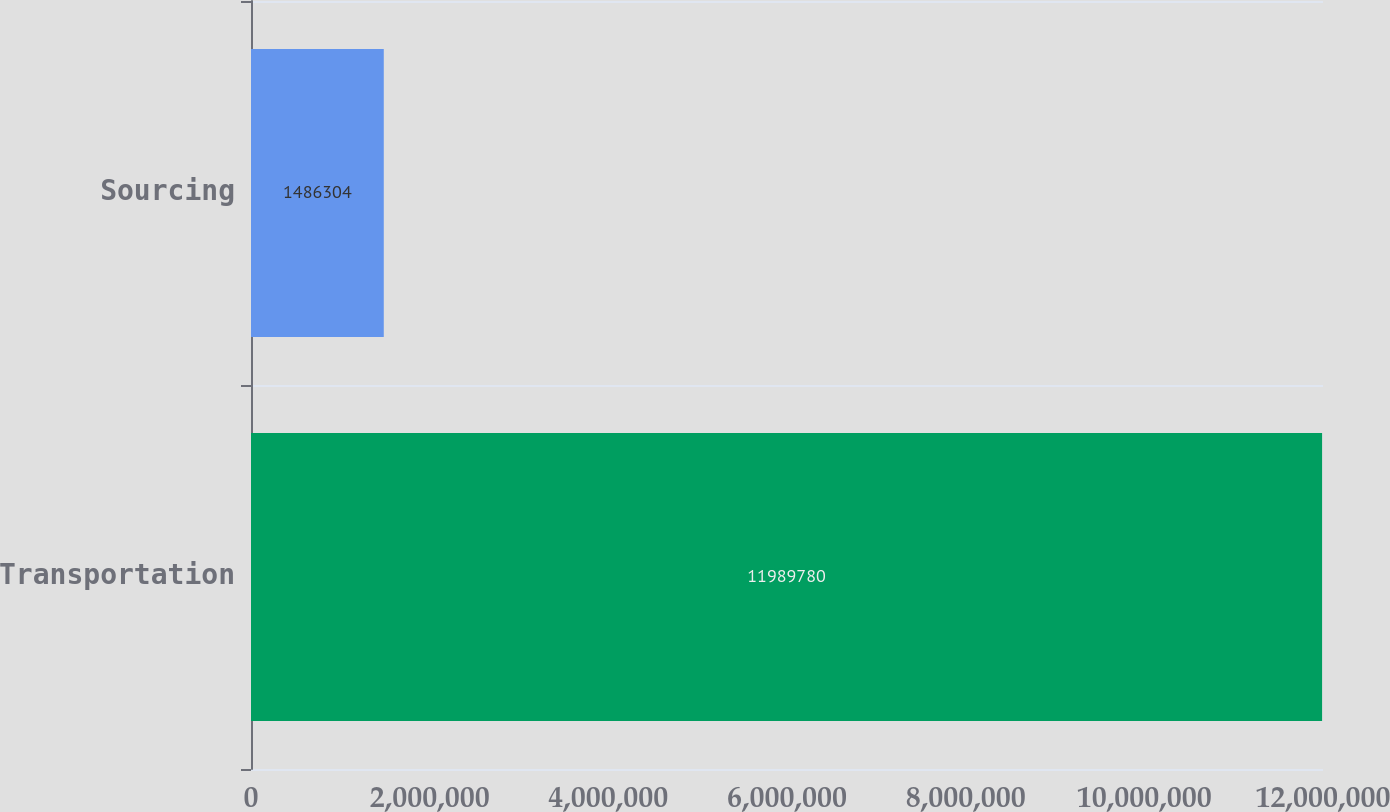Convert chart to OTSL. <chart><loc_0><loc_0><loc_500><loc_500><bar_chart><fcel>Transportation<fcel>Sourcing<nl><fcel>1.19898e+07<fcel>1.4863e+06<nl></chart> 